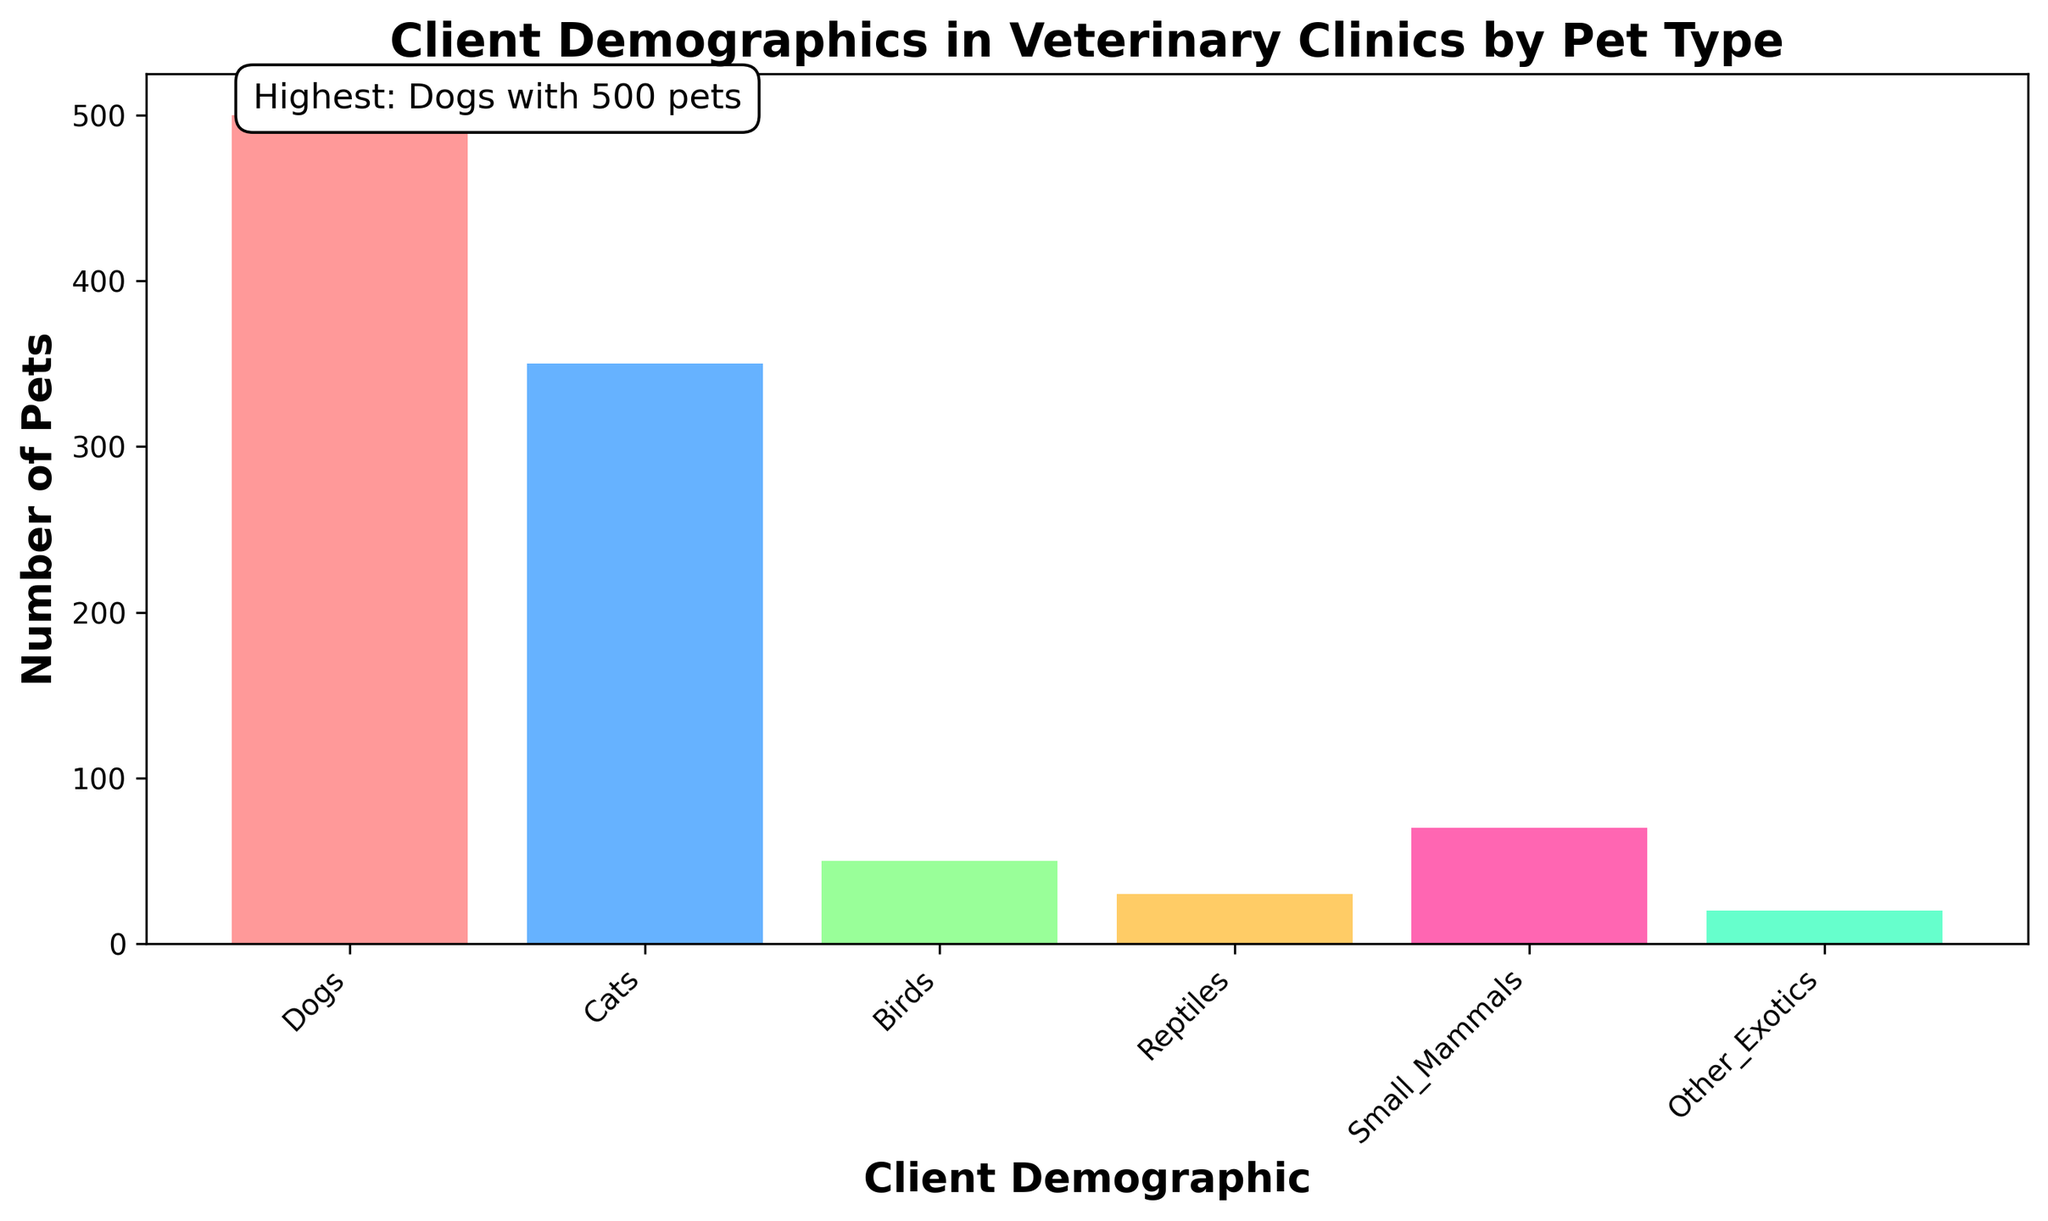What is the total number of pets across all client demographics? Sum up the number of pets for each client demographic: 500 (Dogs) + 350 (Cats) + 50 (Birds) + 30 (Reptiles) + 70 (Small_Mammals) + 20 (Other_Exotics) = 1020
Answer: 1020 Which client demographic has the highest number of pets and how many pets are there? Identify the demographic with the tallest bar, which also has the text annotation "Highest: Dogs with 500 pets" above it
Answer: Dogs, 500 pets How many more pets are there in the "Dogs" demographic compared to the "Cats" demographic? Subtract the number of pets in the "Cats" demographic from the "Dogs" demographic: 500 (Dogs) - 350 (Cats) = 150
Answer: 150 Which demographic has the fewest pets and how many do they have? Identify the demographic with the shortest bar, which corresponds to the "Other_Exotics" demographic with 20 pets
Answer: Other_Exotics, 20 pets What is the sum of the number of pets in the "Birds", "Reptiles", and "Small_Mammals" demographics? Add the number of pets for these demographics: 50 (Birds) + 30 (Reptiles) + 70 (Small_Mammals) = 150
Answer: 150 How does the number of pets in the "Small_Mammals" demographic compare to the "Birds" demographic? Compare the heights of the bars: 70 (Small_Mammals) > 50 (Birds)
Answer: Small_Mammals has more pets What percentage of the total number of pets is represented by the "Cats" demographic? Calculate the percentage by dividing the number of pets in the "Cats" demographic by the total number of pets and multiplying by 100: (350 / 1020) * 100 ≈ 34.31%
Answer: 34.31% Are there more pets in the combined demographics of "Reptiles" and "Other_Exotics" than in "Birds"? Add the number of pets in "Reptiles" and "Other_Exotics" and compare with "Birds": 30 (Reptiles) + 20 (Other_Exotics) = 50, which is equal to 50 (Birds)
Answer: No, they are equal 